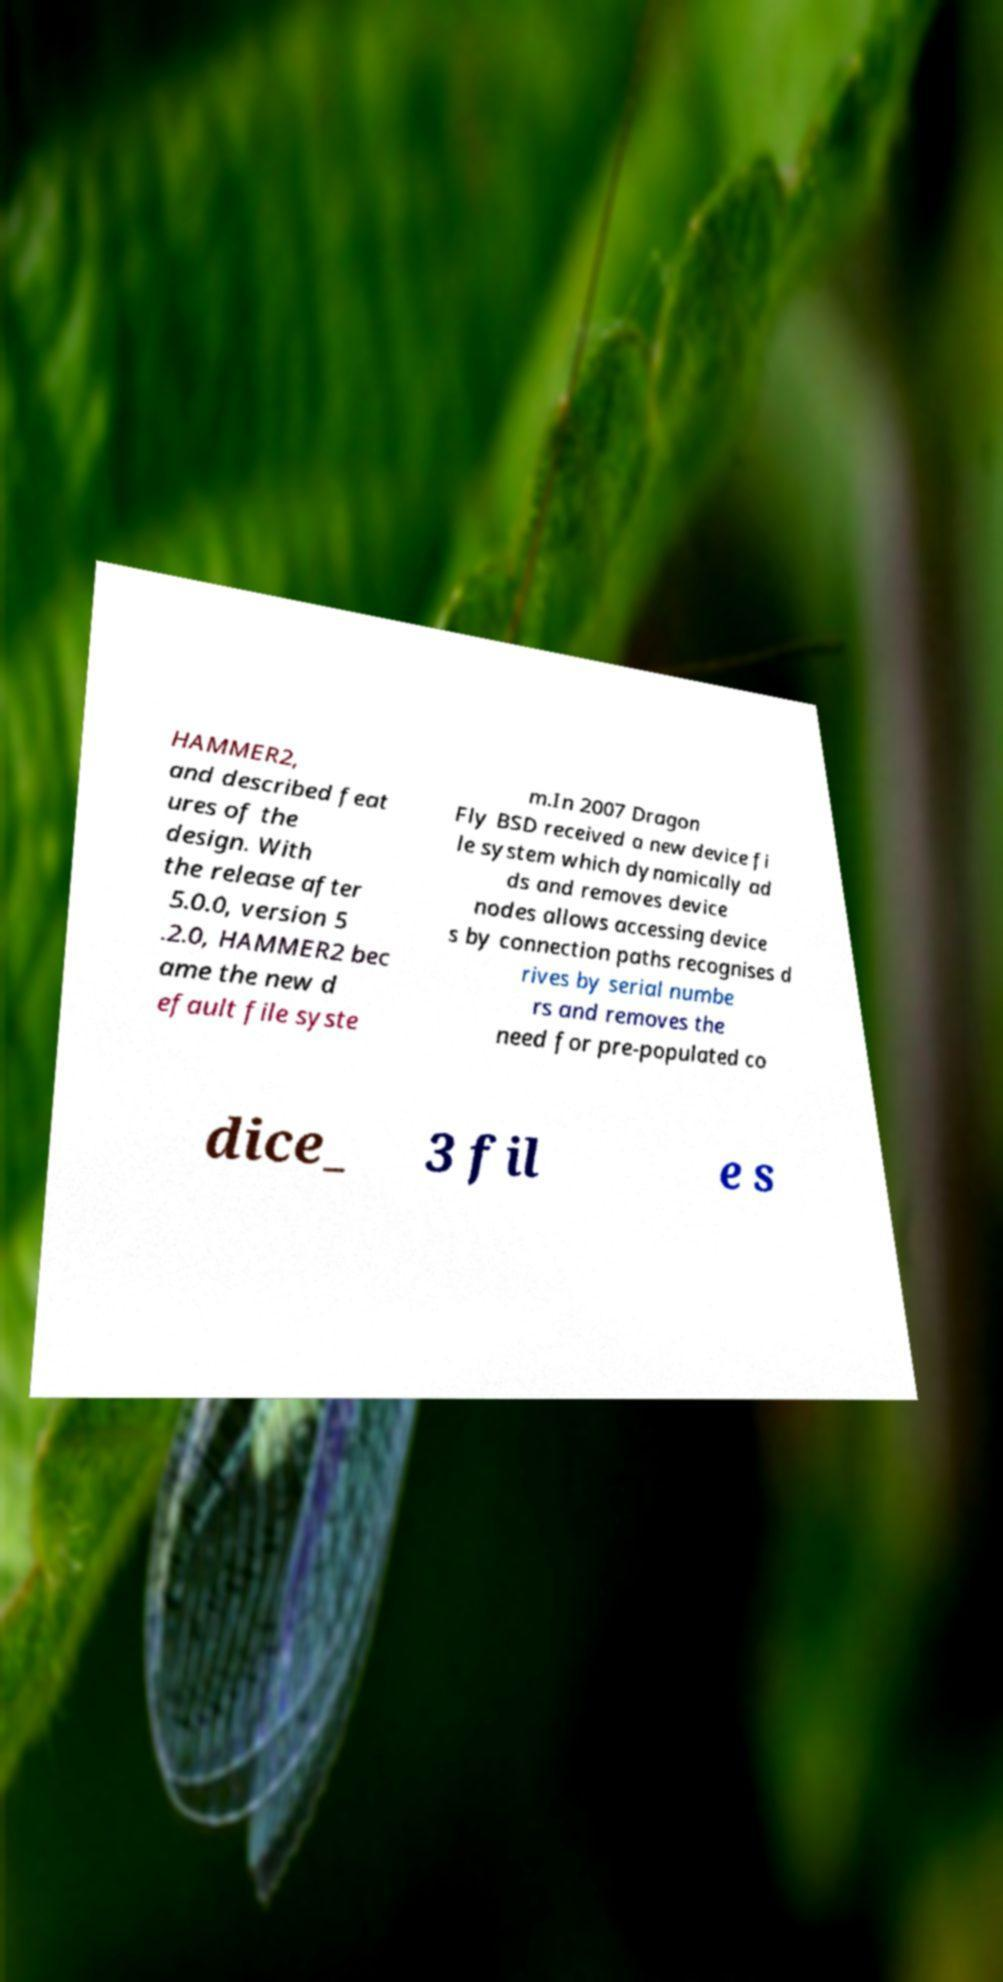Can you read and provide the text displayed in the image?This photo seems to have some interesting text. Can you extract and type it out for me? HAMMER2, and described feat ures of the design. With the release after 5.0.0, version 5 .2.0, HAMMER2 bec ame the new d efault file syste m.In 2007 Dragon Fly BSD received a new device fi le system which dynamically ad ds and removes device nodes allows accessing device s by connection paths recognises d rives by serial numbe rs and removes the need for pre-populated co dice_ 3 fil e s 